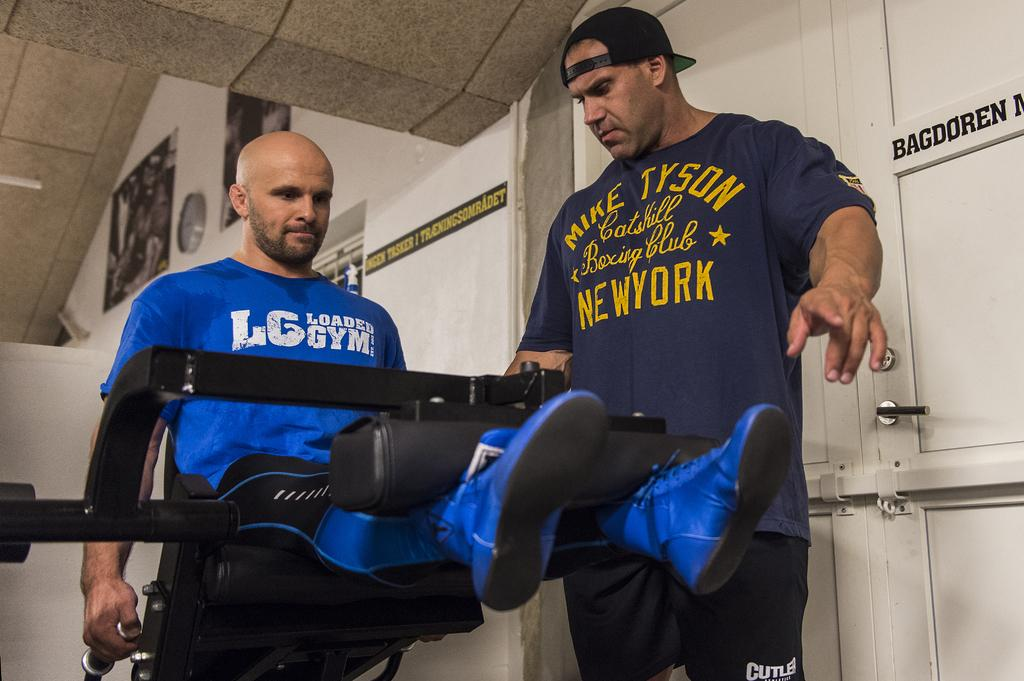<image>
Create a compact narrative representing the image presented. Working out on leg lifts in a blue shirt with LG Loaded Gym in white. 